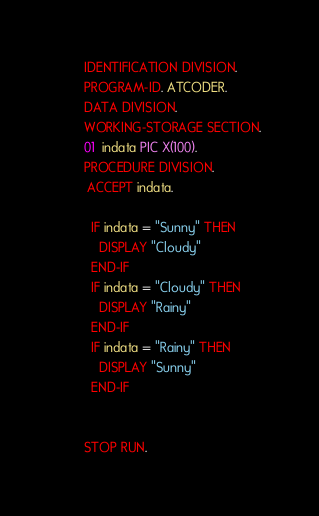Convert code to text. <code><loc_0><loc_0><loc_500><loc_500><_COBOL_>       IDENTIFICATION DIVISION.
       PROGRAM-ID. ATCODER.
       DATA DIVISION.
       WORKING-STORAGE SECTION.
       01  indata PIC X(100).
       PROCEDURE DIVISION.
        ACCEPT indata.
        
         IF indata = "Sunny" THEN
           DISPLAY "Cloudy"
         END-IF
         IF indata = "Cloudy" THEN
           DISPLAY "Rainy"
         END-IF
         IF indata = "Rainy" THEN
           DISPLAY "Sunny"
         END-IF


       STOP RUN.
</code> 